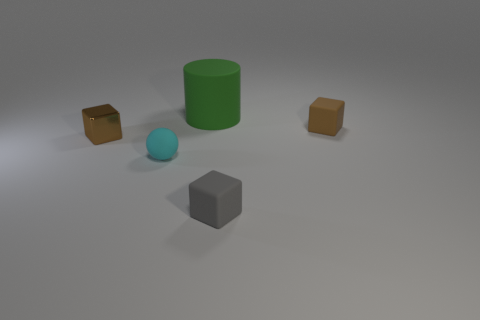What material is the other small cube that is the same color as the tiny metal cube?
Offer a very short reply. Rubber. Are there any other things that are the same shape as the green object?
Your response must be concise. No. There is a large green thing behind the small brown thing that is in front of the small rubber thing that is on the right side of the gray block; what is its shape?
Keep it short and to the point. Cylinder. What number of things are small yellow matte spheres or small cyan matte balls?
Keep it short and to the point. 1. There is a tiny matte object behind the small cyan ball; is its shape the same as the brown object left of the big object?
Your answer should be very brief. Yes. How many rubber objects are both left of the gray matte cube and behind the tiny cyan matte object?
Make the answer very short. 1. What number of other things are there of the same size as the green matte thing?
Keep it short and to the point. 0. The block that is on the right side of the cyan ball and behind the tiny matte sphere is made of what material?
Your response must be concise. Rubber. Does the small metal object have the same color as the tiny rubber cube behind the tiny cyan rubber ball?
Give a very brief answer. Yes. The matte thing that is both behind the metal cube and in front of the cylinder has what shape?
Offer a terse response. Cube. 